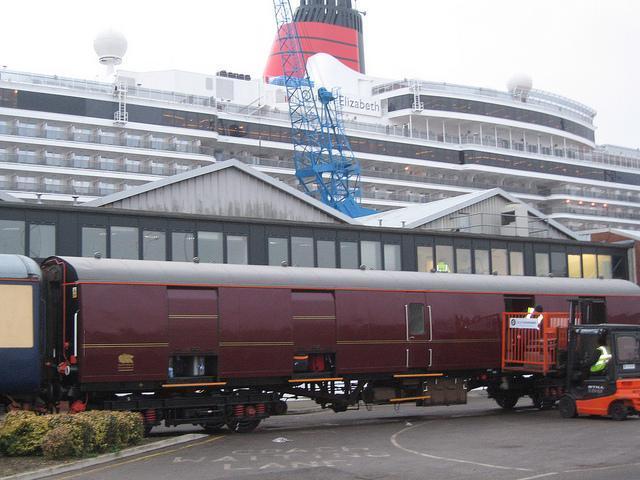How many red chairs here?
Give a very brief answer. 0. 